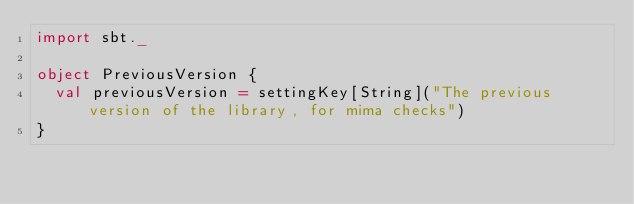Convert code to text. <code><loc_0><loc_0><loc_500><loc_500><_Scala_>import sbt._

object PreviousVersion {
  val previousVersion = settingKey[String]("The previous version of the library, for mima checks")
}
</code> 